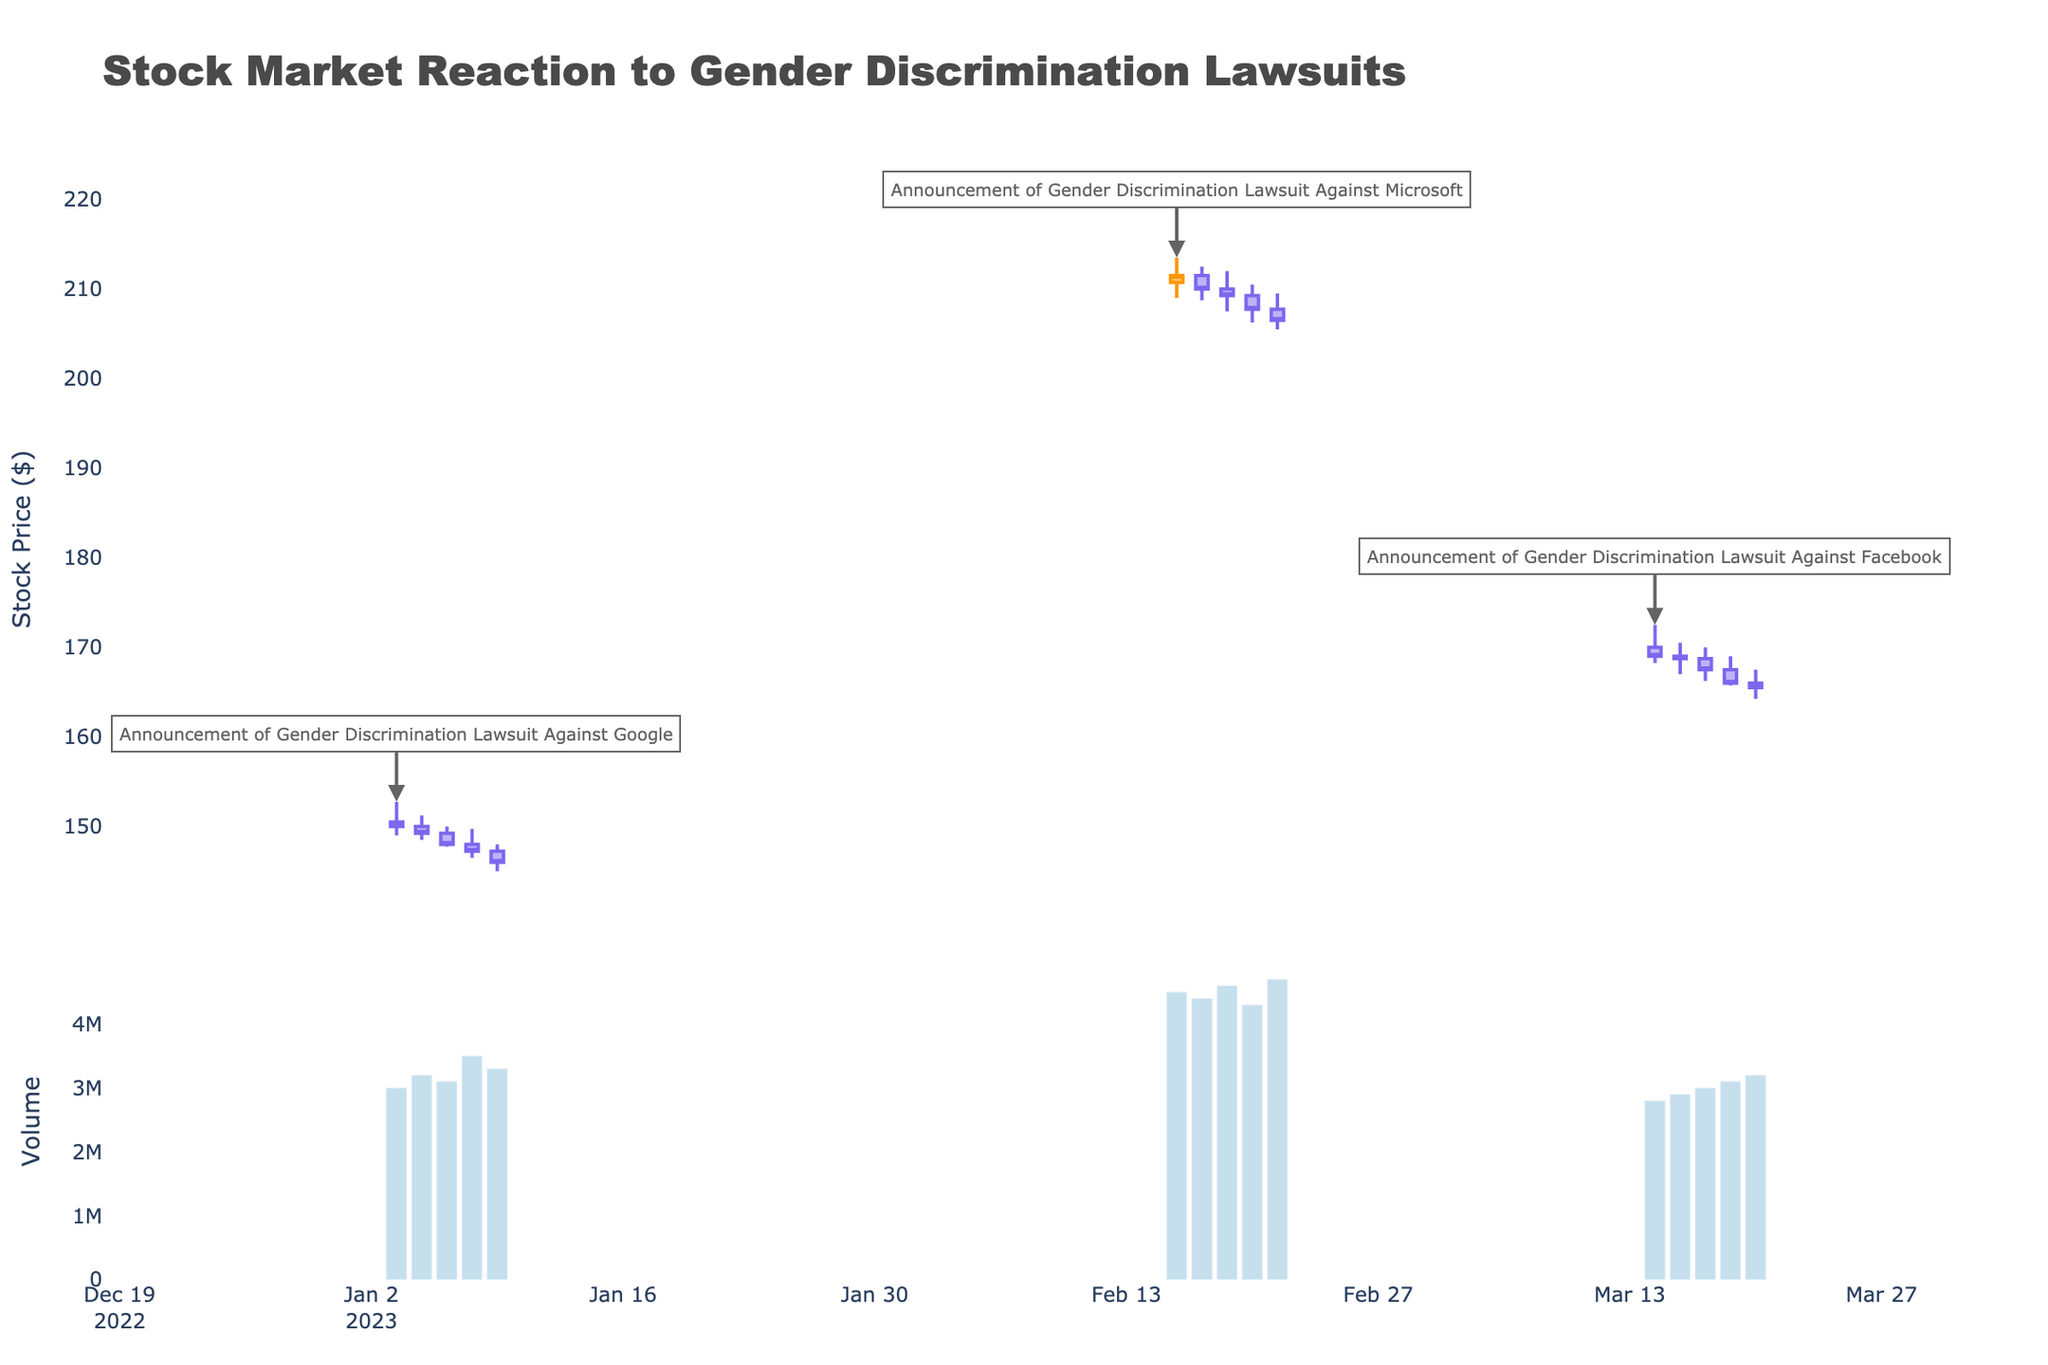what is the title of the figure? The title of the figure is displayed prominently at the top of the plot. It reads "Stock Market Reaction to Gender Discrimination Lawsuits".
Answer: Stock Market Reaction to Gender Discrimination Lawsuits What are the average closing prices on the first two days following the announcement of the lawsuit against Google? The event "Announcement of Gender Discrimination Lawsuit Against Google" occurred on 2023-01-03. The next two days are 2023-01-04 and 2023-01-05. The closing prices for those dates are 149.25 and 148.00 respectively. The average is (149.25 + 148.00) / 2 = 148.625.
Answer: 148.625 How did the stock price react on the day of the announcement of the lawsuit against Microsoft? On 2023-02-15, when the "Announcement of Gender Discrimination Lawsuit Against Microsoft" occurred, the stock opened at 210.75 and closed at 211.50. There was a slight increase in the closing price compared to the opening price.
Answer: It slightly increased Between the lawsuits against Google and Microsoft, which caused a larger volume spike on the announcement day? To determine this, we look at the volume on the announcement days: 2023-01-03 for Google (3,000,000) and 2023-02-15 for Microsoft (4,500,000). Comparing the two, Microsoft had a larger volume spike.
Answer: Microsoft By how much did the stock price fall between the opening and closing price on the day of the Facebook lawsuit announcement? The Facebook lawsuit announcement occurred on 2023-03-14. The stock opened at 170.00 and closed at 169.00. The fall in price is calculated as 170.00 - 169.00 = 1.00.
Answer: 1.00 What is the range of the high and low prices for the stock on 2023-02-16? On 2023-02-16, the high price was 212.50 and the low price was 208.75. The range is calculated as 212.50 - 208.75 = 3.75.
Answer: 3.75 Which event had the lowest closing price on its announcement date? Compare the closing prices on the announcement dates: Google (150.00 on 2023-01-03), Microsoft (211.50 on 2023-02-15), and Facebook (169.00 on 2023-03-14). The lowest closing price is found on the Facebook announcement date.
Answer: Facebook How did the stock price move from the opening to closing on the day after the Facebook lawsuit announcement? The day after the Facebook lawsuit announcement is 2023-03-15. The stock opened at 169.00 and closed at 168.75, indicating a slight decrease.
Answer: It slightly decreased How does the opening price on the announcement date of the gender discrimination lawsuit against Facebook compare to its closing price five days later? The announcement date is 2023-03-14 with an opening price of 170.00. Five days later would be 2023-03-20, and the closing price on that date is 165.50. Comparing the two shows a decrease of 170.00 - 165.50 = 4.50.
Answer: It decreased by 4.50 